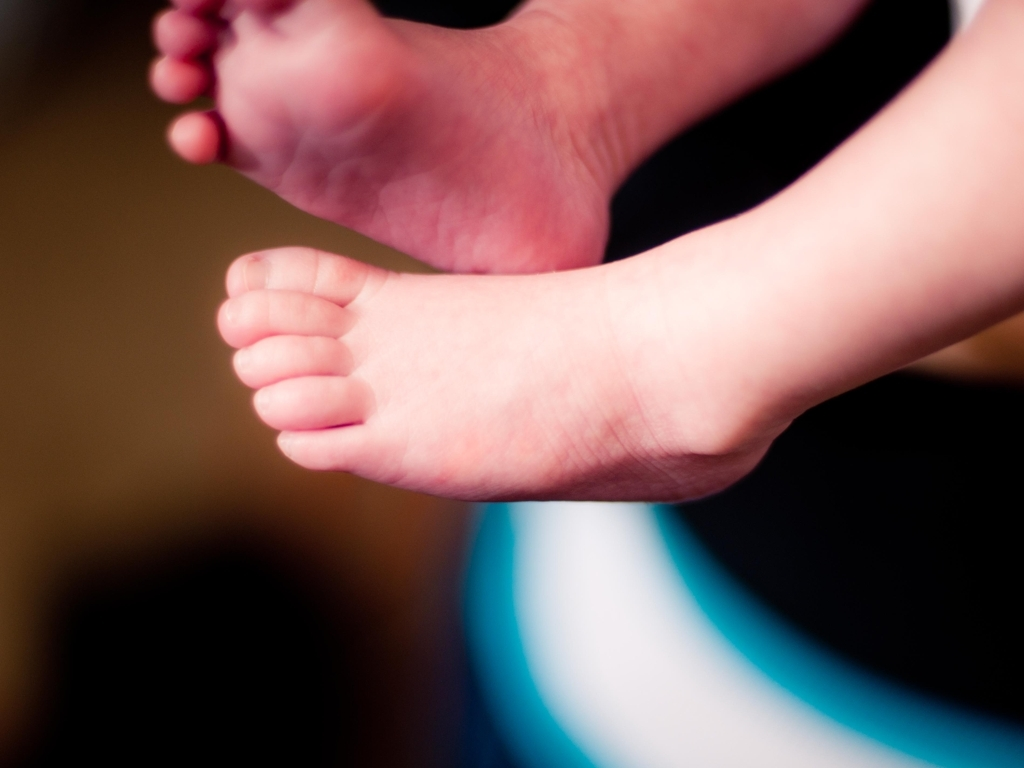What might be the context or setting of this photo? The image likely captures a candid or intimate moment, possibly within a home setting where the child is at ease. The background is out of focus, but the comfortable positioning of the feet implies that the child might be on a soft surface, such as a bed or cushioned area. 